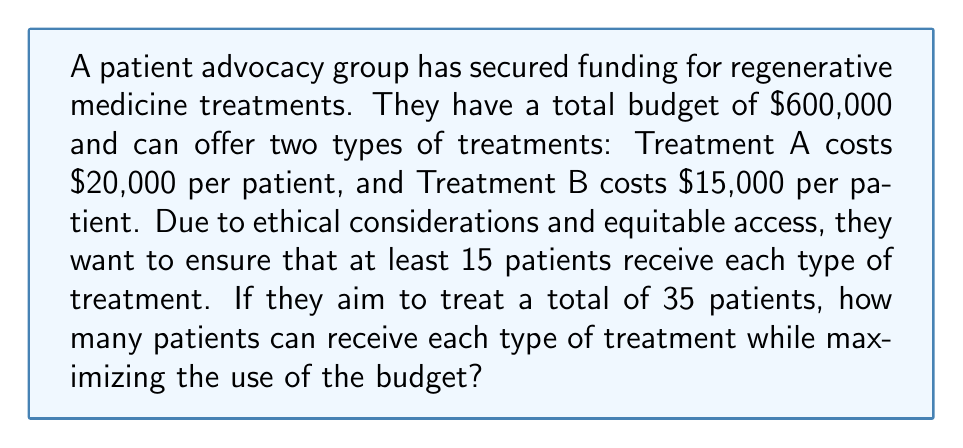Teach me how to tackle this problem. Let's approach this step-by-step using a system of equations:

1. Define variables:
   Let $x$ = number of patients receiving Treatment A
   Let $y$ = number of patients receiving Treatment B

2. Set up equations based on the given information:
   a) Total patients equation: $x + y = 35$
   b) Budget constraint equation: $20000x + 15000y \leq 600000$

3. Additional constraints:
   $x \geq 15$ and $y \geq 15$ (at least 15 patients for each treatment)

4. Solve the total patients equation for $y$:
   $y = 35 - x$

5. Substitute this into the budget constraint equation:
   $20000x + 15000(35 - x) \leq 600000$

6. Simplify:
   $20000x + 525000 - 15000x \leq 600000$
   $5000x + 525000 \leq 600000$
   $5000x \leq 75000$
   $x \leq 15$

7. Given the constraint $x \geq 15$ and the result $x \leq 15$, we can conclude:
   $x = 15$

8. Substitute back to find $y$:
   $y = 35 - 15 = 20$

9. Verify the budget constraint:
   $20000(15) + 15000(20) = 300000 + 300000 = 600000$

Therefore, the maximum number of patients that can be treated while satisfying all constraints is 15 for Treatment A and 20 for Treatment B.
Answer: 15 patients for Treatment A, 20 patients for Treatment B 